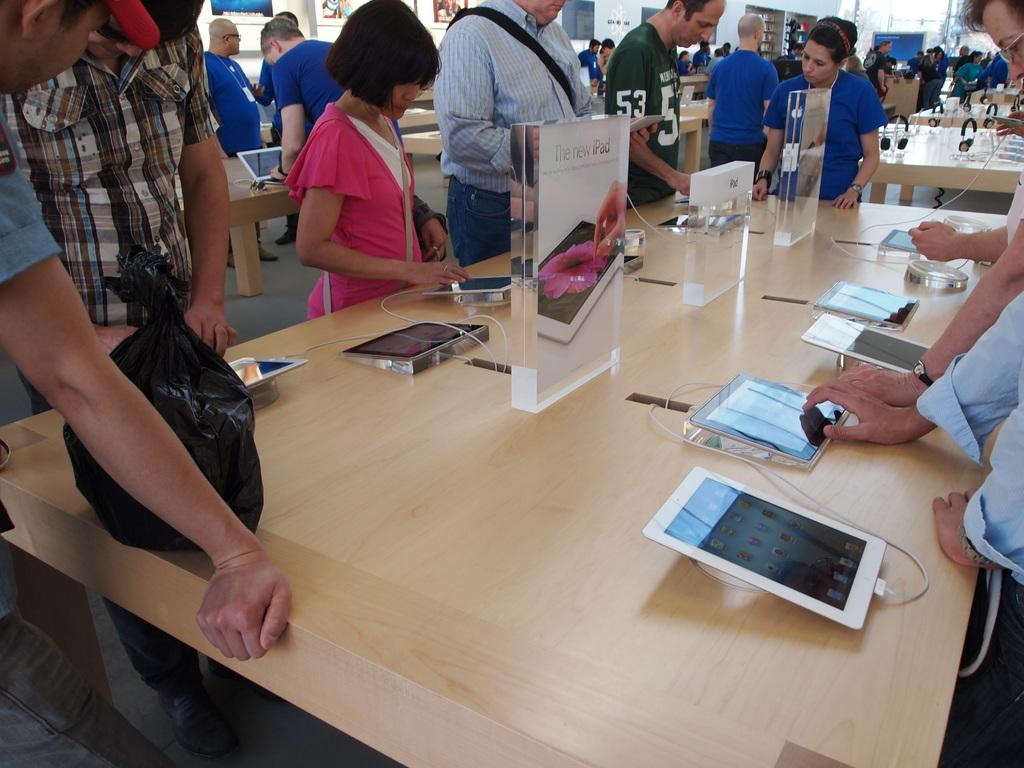What are the people in the image doing? There is a group of people standing in the image. What objects can be seen on the tables in the image? On the tables, there are tabs, boards, and cables visible. What part of the room can be seen in the image? The floor is visible in the image. How many visitors are present in the image? There is no mention of visitors in the image; it only shows a group of people standing. Can you describe the jump that the person in the image is performing? There is no person jumping in the image; the people are standing. 